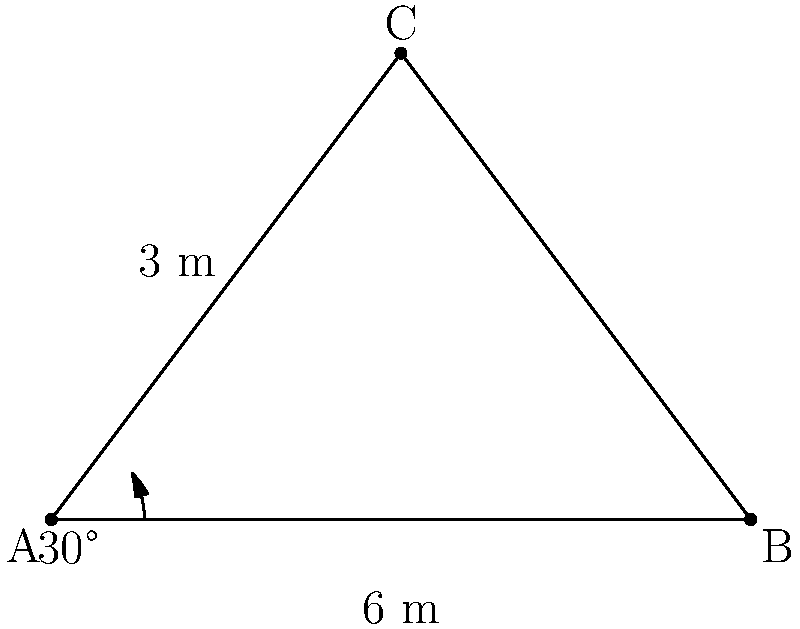In your latest crime novel, a hidden surveillance camera is placed at point C in a triangular room. The camera's field of view is represented by angle ACB. If the distance AB is 6 meters and the perpendicular distance from C to AB is 3 meters, what is the angle of view (ACB) of the camera? To solve this problem, we'll use trigonometry:

1. The room forms a right-angled triangle, with the right angle at the base of the perpendicular from C to AB.

2. We can split this triangle into two right-angled triangles by this perpendicular.

3. Let's focus on one of these right-angled triangles. We know:
   - The adjacent side (half of AB) = 6/2 = 3 meters
   - The opposite side (height from C to AB) = 3 meters

4. We can use the tangent function to find half of the angle ACB:
   $\tan(\frac{1}{2}\angle ACB) = \frac{\text{opposite}}{\text{adjacent}} = \frac{3}{3} = 1$

5. The angle whose tangent is 1 is 45°:
   $\frac{1}{2}\angle ACB = \arctan(1) = 45°$

6. Therefore, the full angle ACB is:
   $\angle ACB = 2 * 45° = 90°$

Thus, the angle of view of the camera is 90°.
Answer: 90° 